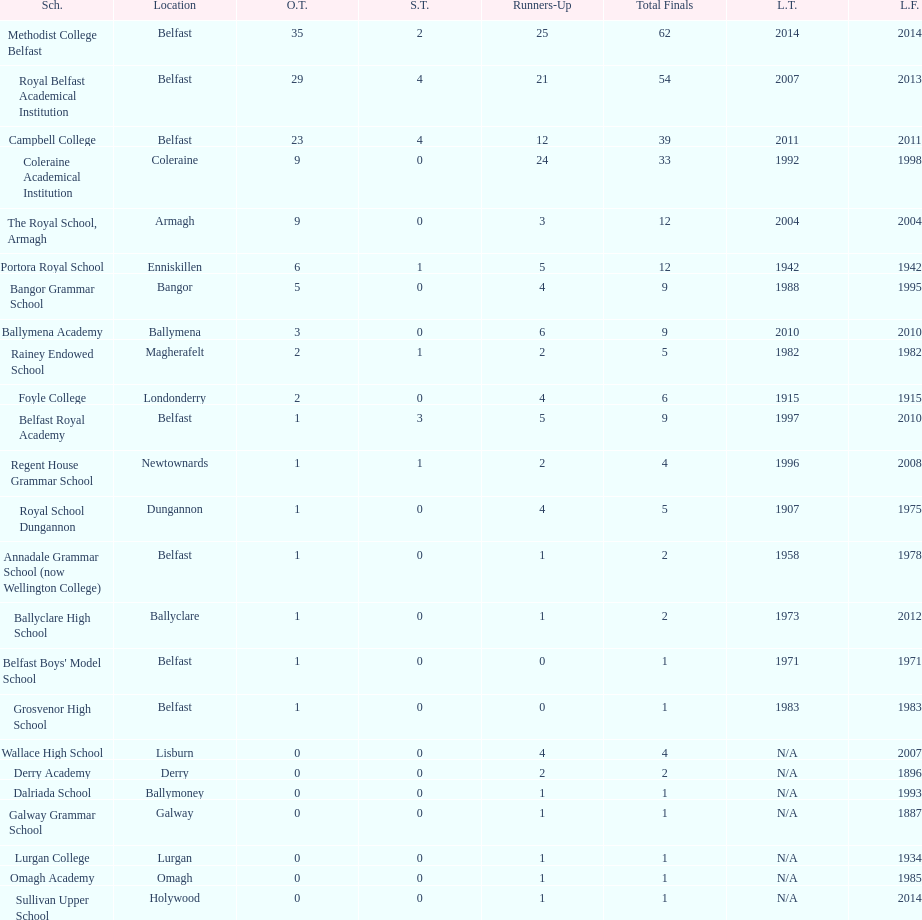In what ways are the runners-up from coleraine academical institution and royal school dungannon dissimilar? 20. 